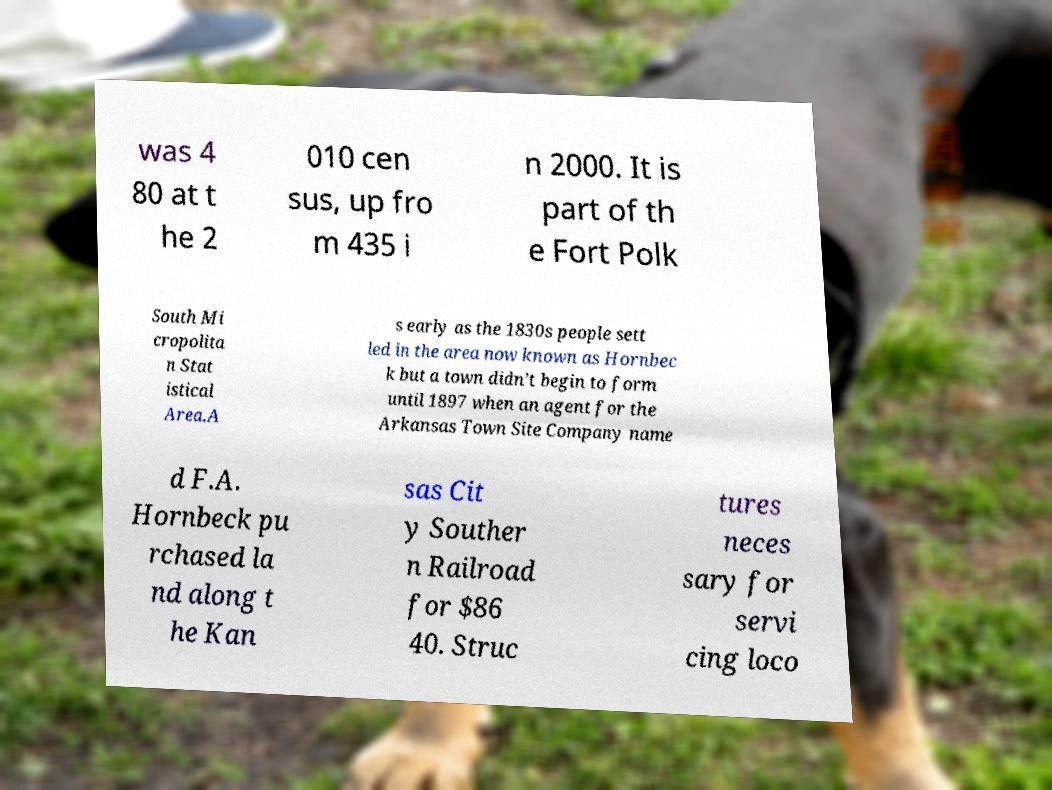There's text embedded in this image that I need extracted. Can you transcribe it verbatim? was 4 80 at t he 2 010 cen sus, up fro m 435 i n 2000. It is part of th e Fort Polk South Mi cropolita n Stat istical Area.A s early as the 1830s people sett led in the area now known as Hornbec k but a town didn’t begin to form until 1897 when an agent for the Arkansas Town Site Company name d F.A. Hornbeck pu rchased la nd along t he Kan sas Cit y Souther n Railroad for $86 40. Struc tures neces sary for servi cing loco 